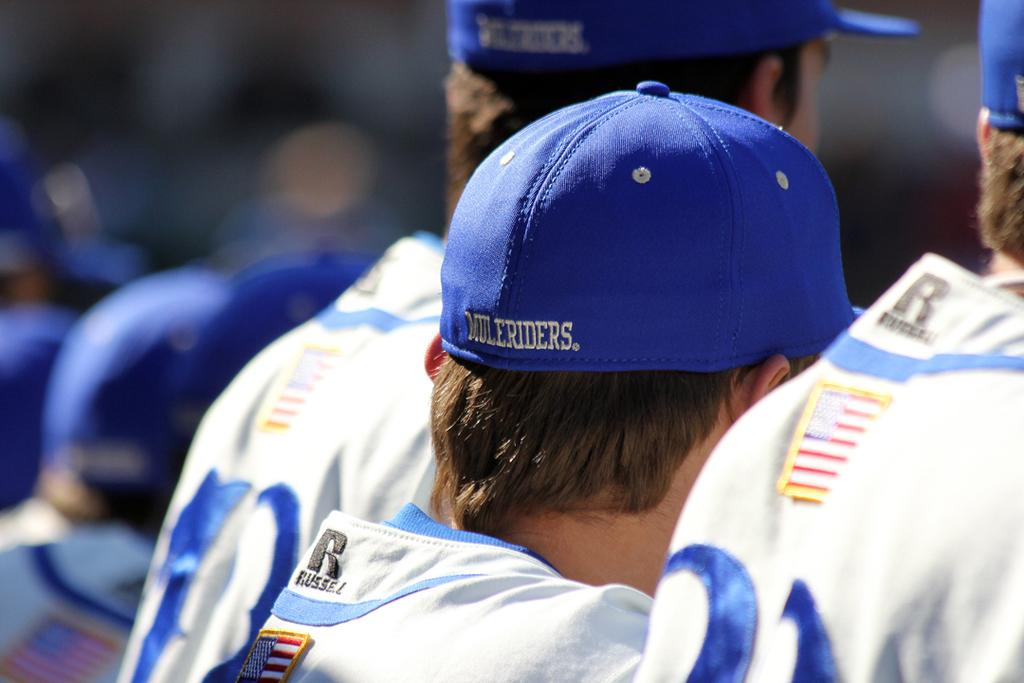<image>
Summarize the visual content of the image. A man wears a blue hat that reads "Muleriders" on the back. 